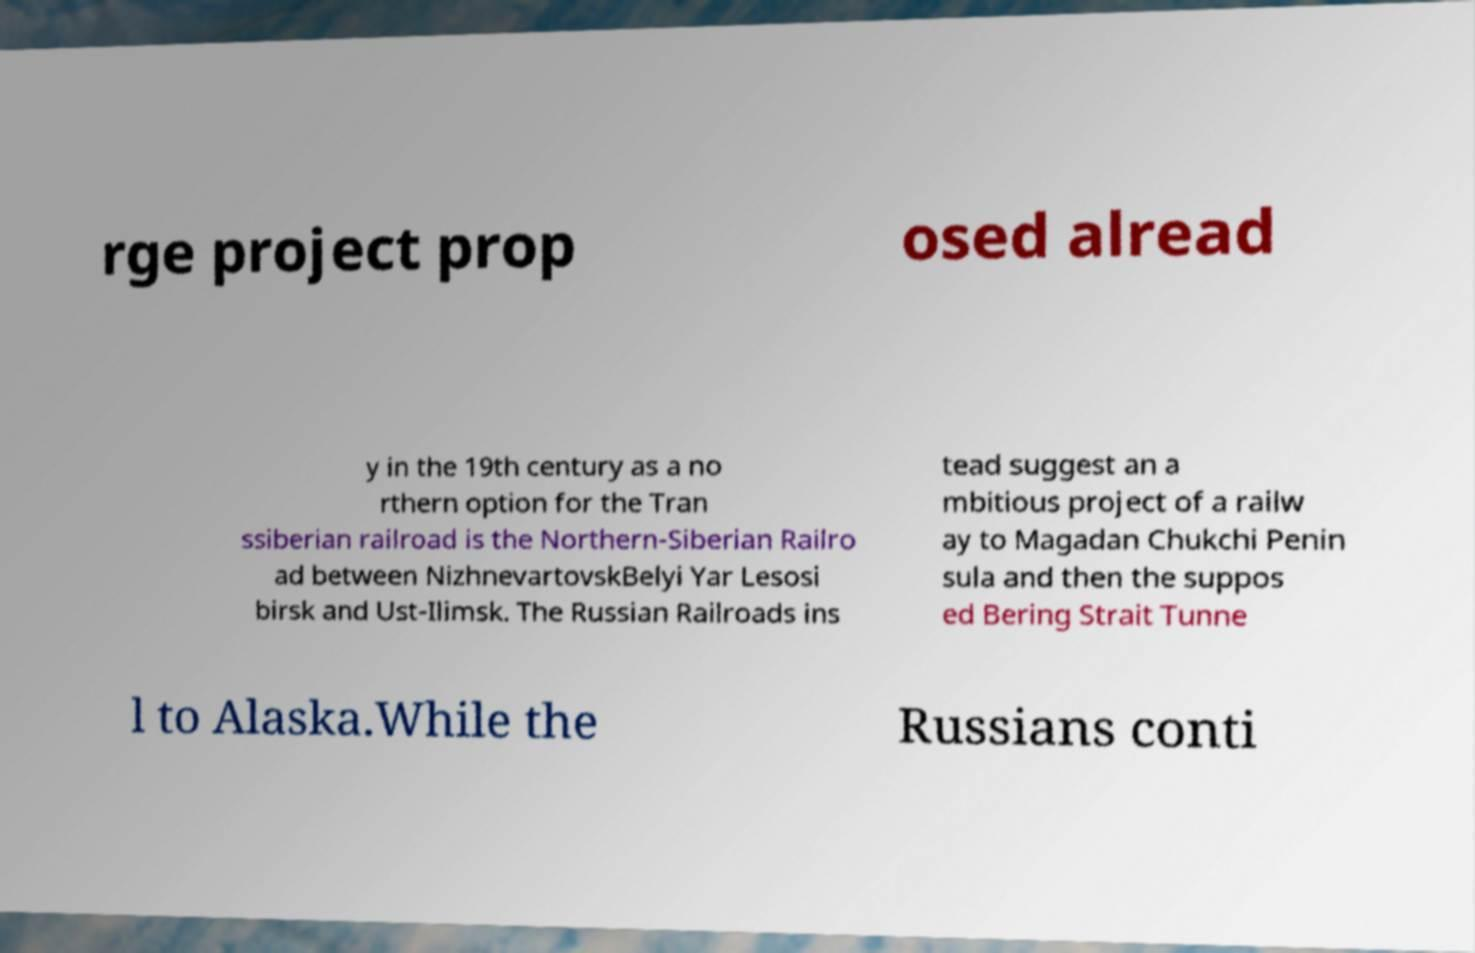Can you read and provide the text displayed in the image?This photo seems to have some interesting text. Can you extract and type it out for me? rge project prop osed alread y in the 19th century as a no rthern option for the Tran ssiberian railroad is the Northern-Siberian Railro ad between NizhnevartovskBelyi Yar Lesosi birsk and Ust-Ilimsk. The Russian Railroads ins tead suggest an a mbitious project of a railw ay to Magadan Chukchi Penin sula and then the suppos ed Bering Strait Tunne l to Alaska.While the Russians conti 